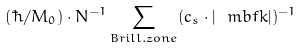<formula> <loc_0><loc_0><loc_500><loc_500>( \hbar { / } M _ { 0 } ) \cdot N ^ { - 1 } \sum _ { B r i l l . z o n e } ( c _ { s } \cdot | \ m b f { k } | ) ^ { - 1 }</formula> 